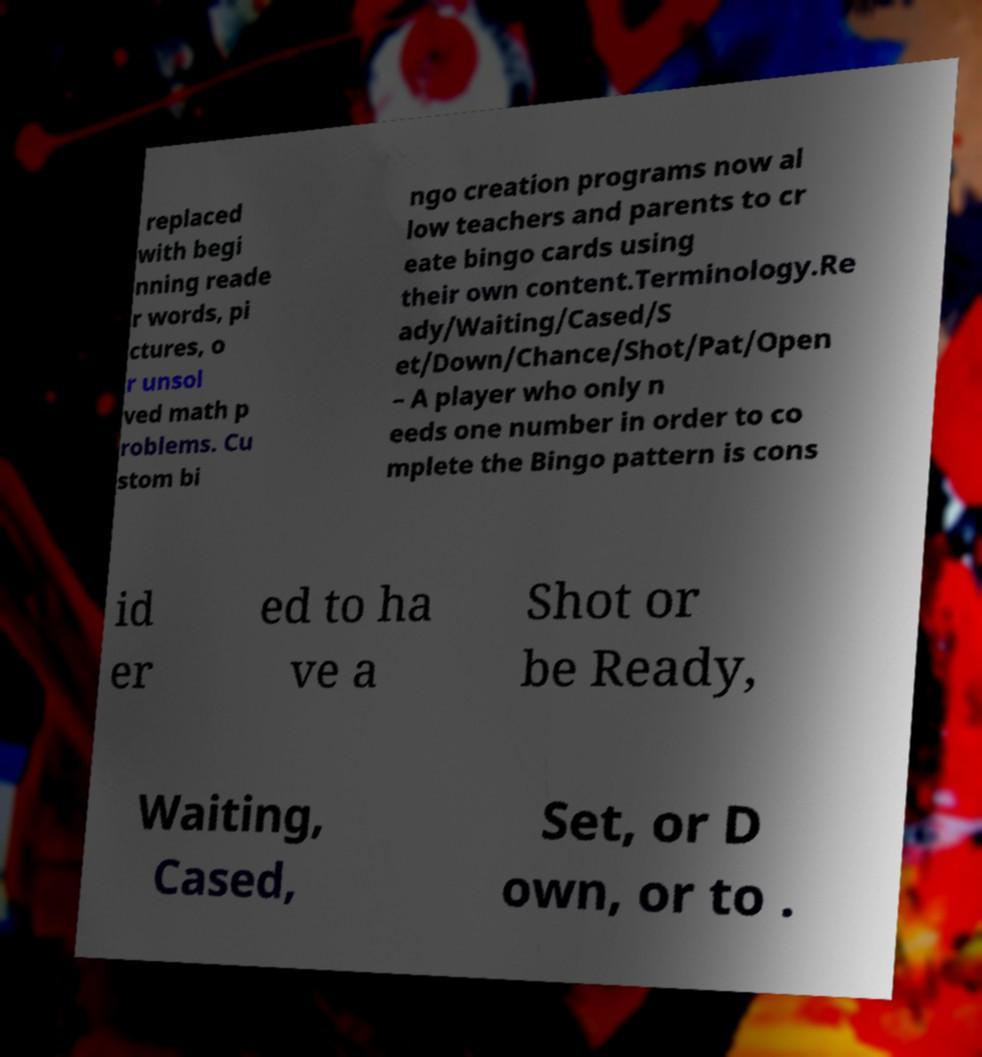Could you extract and type out the text from this image? replaced with begi nning reade r words, pi ctures, o r unsol ved math p roblems. Cu stom bi ngo creation programs now al low teachers and parents to cr eate bingo cards using their own content.Terminology.Re ady/Waiting/Cased/S et/Down/Chance/Shot/Pat/Open – A player who only n eeds one number in order to co mplete the Bingo pattern is cons id er ed to ha ve a Shot or be Ready, Waiting, Cased, Set, or D own, or to . 